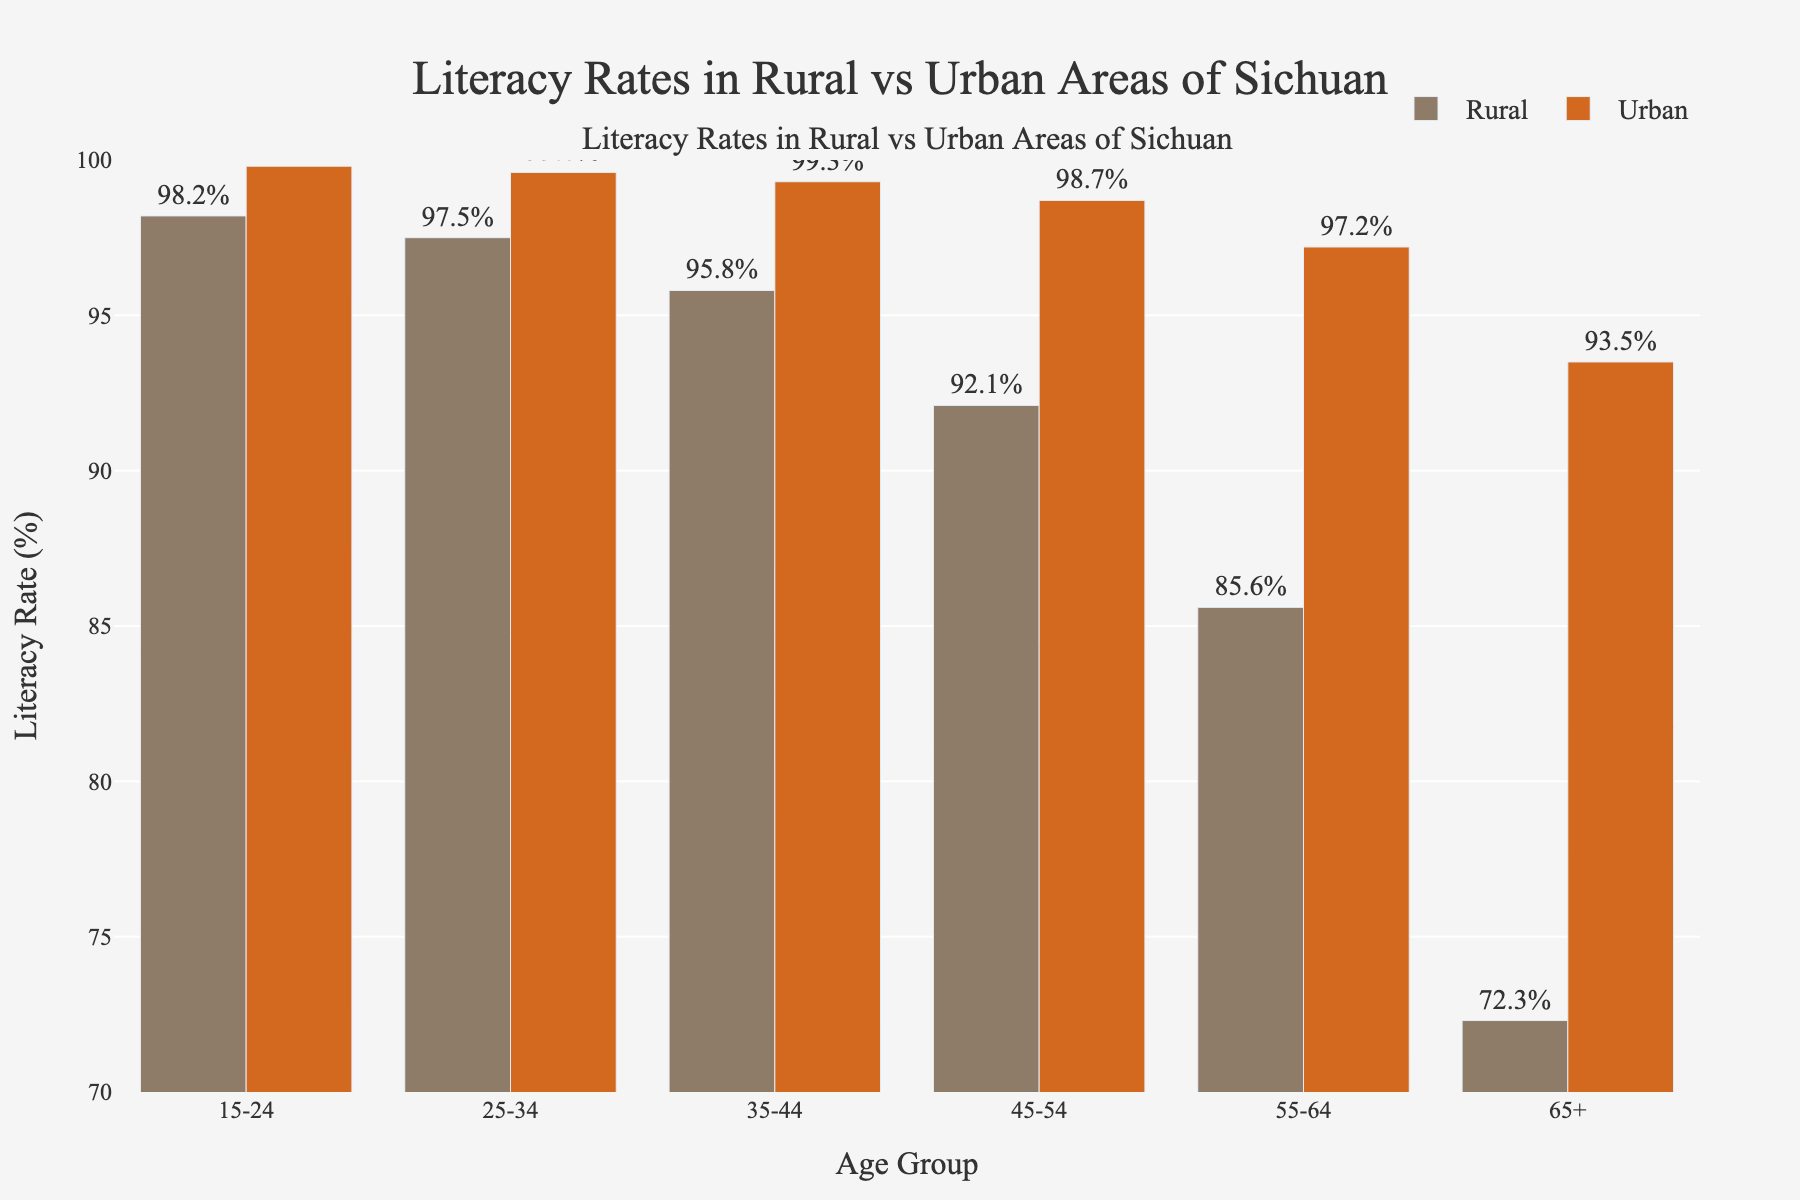What's the literacy rate difference between urban and rural areas for the 65+ age group? The urban literacy rate for the 65+ age group is 93.5%, while the rural literacy rate is 72.3%. The difference is 93.5% - 72.3%
Answer: 21.2% Which age group has the smallest gap in literacy rates between urban and rural areas? To find the smallest gap, we calculate the literacy rate differences for all age groups: 
- 15-24: 99.8% - 98.2% = 1.6%
- 25-34: 99.6% - 97.5% = 2.1%
- 35-44: 99.3% - 95.8% = 3.5%
- 45-54: 98.7% - 92.1% = 6.6%
- 55-64: 97.2% - 85.6% = 11.6%
- 65+: 93.5% - 72.3% = 21.2%
The smallest gap is 1.6% for the 15-24 age group
Answer: 15-24 Is the rural or urban literacy rate higher for the 55-64 age group? The bar for the urban literacy rate of the 55-64 age group is visually higher than that for the rural literacy rate. The urban literacy rate is 97.2%, and the rural literacy rate is 85.6%
Answer: Urban What is the approximate average literacy rate for urban areas across all age groups? To find the average, add up the urban literacy rates for all age groups and then divide by the number of groups (99.8% + 99.6% + 99.3% + 98.7% + 97.2% + 93.5%) / 6 = 588.1% / 6
Answer: 98.0% Which age group has the lowest literacy rate in rural areas? By examining the heights of the bars for rural literacy rates, the 65+ age group has the shortest bar, indicating the lowest literacy rate at 72.3%
Answer: 65+ How do the literacy rates for the 45-54 age group compare between rural and urban areas? The urban literacy rate for the 45-54 age group is 98.7%, which is higher than the rural literacy rate of 92.1%. The difference is 98.7% - 92.1%
Answer: Urban has 6.6% higher What is the difference in literacy rates between the 35-44 and 55-64 age groups in urban areas? The urban literacy rate for the 35-44 age group is 99.3%, and for the 55-64 age group, it is 97.2%. The difference is 99.3% - 97.2%
Answer: 2.1% Which age group shows the steepest decline in literacy rates when comparing rural to urban areas? To determine the steepest decline, compare the differences in percentages between urban and rural literacy rates for each group. From the calculations:
- 15-24: 1.6%
- 25-34: 2.1%
- 35-44: 3.5%
- 45-54: 6.6%
- 55-64: 11.6%
- 65+: 21.2%
The steepest decline is 21.2% in the 65+ age group
Answer: 65+ 